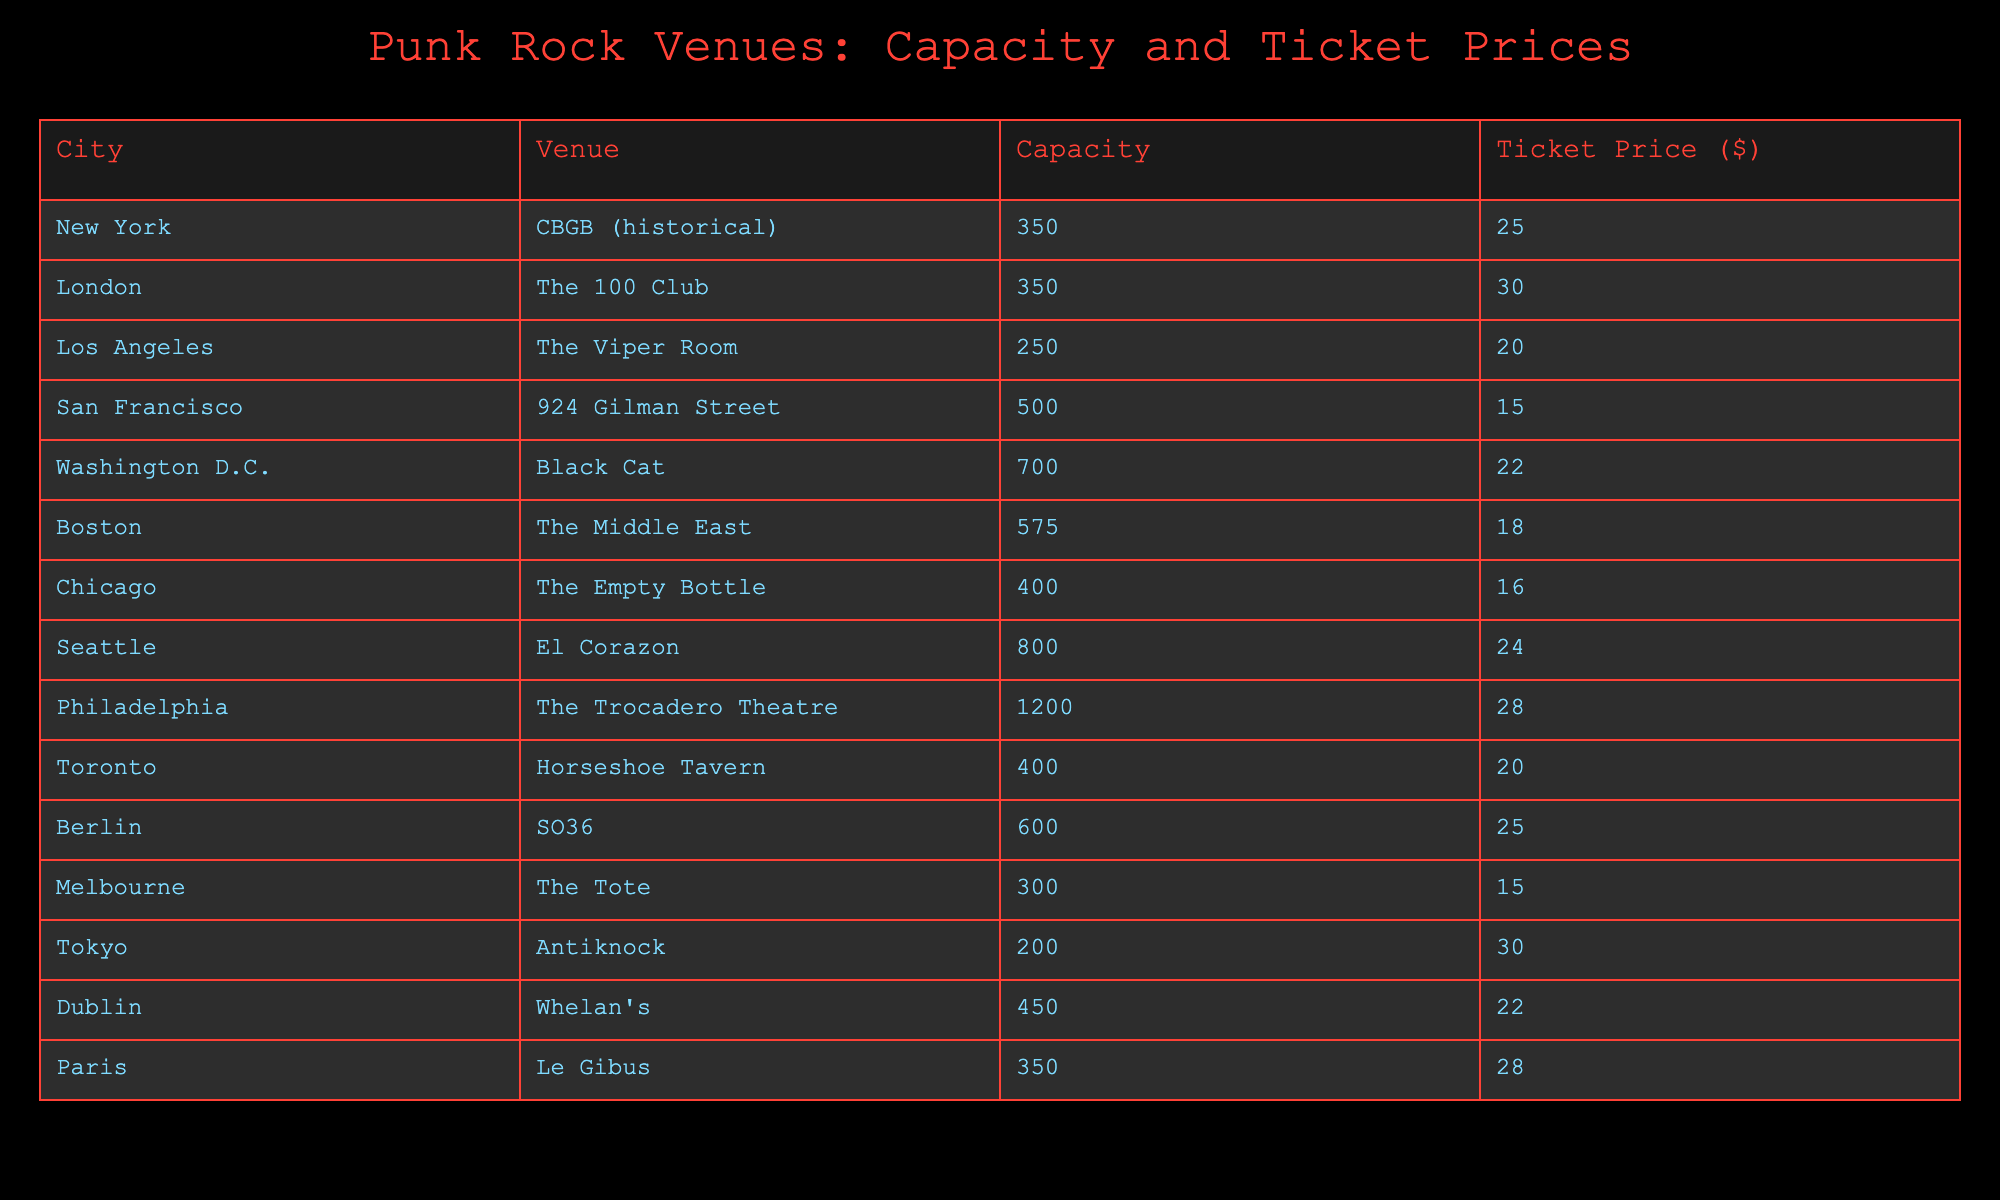What's the highest ticket price among the venues listed? The ticket prices listed in the table are 25, 30, 20, 15, 22, 18, 16, 24, 28, 20, 25, 15, 30, and 22. The highest value among these is 30.
Answer: 30 Which city has the venue with the largest capacity? The capacities listed in the table are 350, 350, 250, 500, 700, 575, 400, 800, 1200, 400, 600, 300, 200, and 450. The largest capacity is 1200, which is in Philadelphia at The Trocadero Theatre.
Answer: Philadelphia How many venues have a capacity greater than 500? The capacities greater than 500 are noted for Black Cat (700), Seattle (800), and Philadelphia (1200). This totals three venues.
Answer: 3 What is the average ticket price for all the venues? Adding the ticket prices (25 + 30 + 20 + 15 + 22 + 18 + 16 + 24 + 28 + 20 + 25 + 15 + 30 + 22) gives  320. There are 14 venues, so the average is 320/14, which is approximately 22.86.
Answer: 22.86 Which city has the lowest capacity venue, and what is that capacity? The capacities listed in the table are 350, 350, 250, 500, 700, 575, 400, 800, 1200, 400, 600, 300, 200, and 450. The lowest capacity is 200, which is in Tokyo at Antiknock.
Answer: Tokyo, 200 Is there a venue in Los Angeles with a ticket price below $25? The ticket price for The Viper Room in Los Angeles is $20, which is below $25. So, the answer is yes.
Answer: Yes How much more is the average ticket price of venues in Europe compared to those in the US? The ticket prices for European venues (The 100 Club, SO36, Whelan's, Le Gibus) are 30, 25, 22, and 28 respectively, averaging (30+25+22+28)/4 = 26.25. The US venues (CBGB, The Viper Room, Black Cat, The Middle East, The Empty Bottle, El Corazon, The Trocadero Theatre) average (25+20+22+18+16+24+28)/7 = 22.14. The difference is 26.25 - 22.14 = 4.11.
Answer: 4.11 What is the total capacity of venues in the city with the most venues listed? Philadelphia has the most venues, with a total capacity of 1200 for The Trocadero Theatre. No other city has more than one entry.
Answer: 1200 Which city has the most expensive venue, and what is its ticket price? Among the cities, The 100 Club in London has a ticket price of $30, which is the highest listed in the table.
Answer: London, 30 